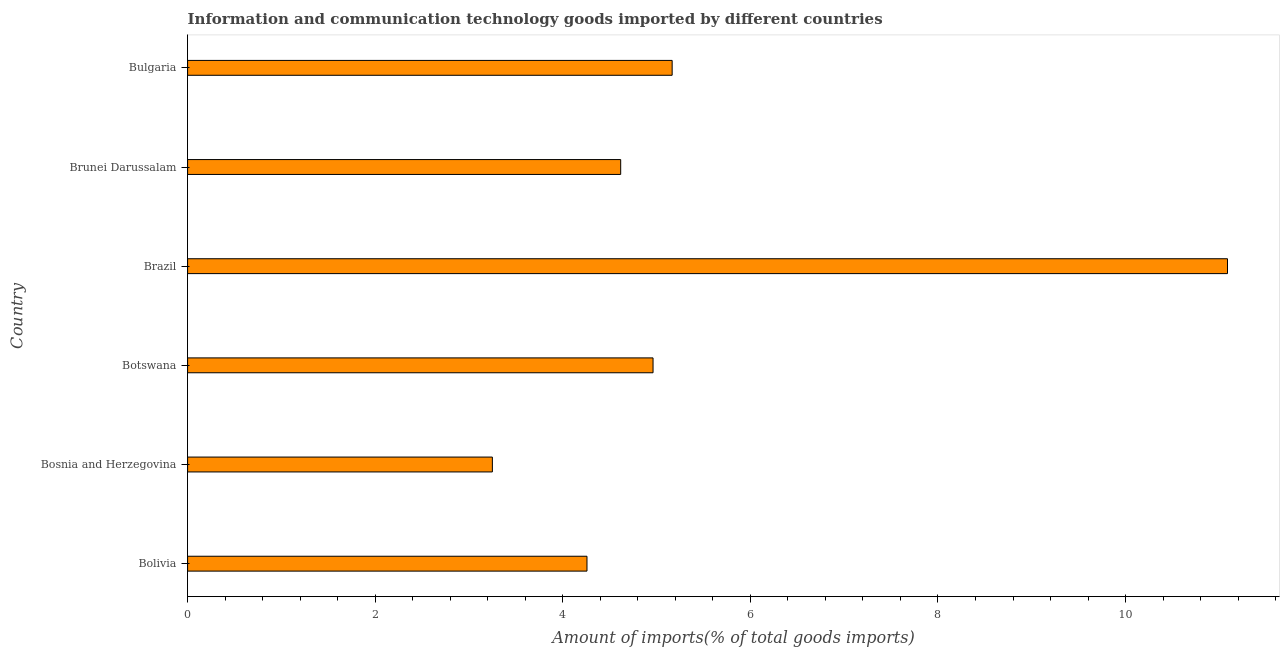Does the graph contain grids?
Your response must be concise. No. What is the title of the graph?
Your response must be concise. Information and communication technology goods imported by different countries. What is the label or title of the X-axis?
Make the answer very short. Amount of imports(% of total goods imports). What is the label or title of the Y-axis?
Offer a very short reply. Country. What is the amount of ict goods imports in Bosnia and Herzegovina?
Your answer should be compact. 3.25. Across all countries, what is the maximum amount of ict goods imports?
Provide a short and direct response. 11.09. Across all countries, what is the minimum amount of ict goods imports?
Ensure brevity in your answer.  3.25. In which country was the amount of ict goods imports minimum?
Offer a terse response. Bosnia and Herzegovina. What is the sum of the amount of ict goods imports?
Your answer should be compact. 33.34. What is the difference between the amount of ict goods imports in Botswana and Brazil?
Keep it short and to the point. -6.12. What is the average amount of ict goods imports per country?
Your answer should be compact. 5.56. What is the median amount of ict goods imports?
Your response must be concise. 4.79. In how many countries, is the amount of ict goods imports greater than 6.8 %?
Your answer should be very brief. 1. What is the ratio of the amount of ict goods imports in Bosnia and Herzegovina to that in Brazil?
Make the answer very short. 0.29. What is the difference between the highest and the second highest amount of ict goods imports?
Provide a succinct answer. 5.92. What is the difference between the highest and the lowest amount of ict goods imports?
Provide a short and direct response. 7.84. Are all the bars in the graph horizontal?
Your response must be concise. Yes. How many countries are there in the graph?
Keep it short and to the point. 6. What is the Amount of imports(% of total goods imports) of Bolivia?
Provide a short and direct response. 4.26. What is the Amount of imports(% of total goods imports) in Bosnia and Herzegovina?
Give a very brief answer. 3.25. What is the Amount of imports(% of total goods imports) of Botswana?
Your answer should be very brief. 4.96. What is the Amount of imports(% of total goods imports) in Brazil?
Provide a short and direct response. 11.09. What is the Amount of imports(% of total goods imports) in Brunei Darussalam?
Provide a short and direct response. 4.62. What is the Amount of imports(% of total goods imports) in Bulgaria?
Offer a very short reply. 5.17. What is the difference between the Amount of imports(% of total goods imports) in Bolivia and Bosnia and Herzegovina?
Ensure brevity in your answer.  1.01. What is the difference between the Amount of imports(% of total goods imports) in Bolivia and Botswana?
Your answer should be compact. -0.7. What is the difference between the Amount of imports(% of total goods imports) in Bolivia and Brazil?
Offer a terse response. -6.83. What is the difference between the Amount of imports(% of total goods imports) in Bolivia and Brunei Darussalam?
Provide a succinct answer. -0.36. What is the difference between the Amount of imports(% of total goods imports) in Bolivia and Bulgaria?
Give a very brief answer. -0.91. What is the difference between the Amount of imports(% of total goods imports) in Bosnia and Herzegovina and Botswana?
Ensure brevity in your answer.  -1.71. What is the difference between the Amount of imports(% of total goods imports) in Bosnia and Herzegovina and Brazil?
Make the answer very short. -7.84. What is the difference between the Amount of imports(% of total goods imports) in Bosnia and Herzegovina and Brunei Darussalam?
Ensure brevity in your answer.  -1.37. What is the difference between the Amount of imports(% of total goods imports) in Bosnia and Herzegovina and Bulgaria?
Offer a very short reply. -1.92. What is the difference between the Amount of imports(% of total goods imports) in Botswana and Brazil?
Ensure brevity in your answer.  -6.12. What is the difference between the Amount of imports(% of total goods imports) in Botswana and Brunei Darussalam?
Offer a very short reply. 0.34. What is the difference between the Amount of imports(% of total goods imports) in Botswana and Bulgaria?
Provide a succinct answer. -0.2. What is the difference between the Amount of imports(% of total goods imports) in Brazil and Brunei Darussalam?
Your answer should be very brief. 6.47. What is the difference between the Amount of imports(% of total goods imports) in Brazil and Bulgaria?
Offer a terse response. 5.92. What is the difference between the Amount of imports(% of total goods imports) in Brunei Darussalam and Bulgaria?
Ensure brevity in your answer.  -0.55. What is the ratio of the Amount of imports(% of total goods imports) in Bolivia to that in Bosnia and Herzegovina?
Your answer should be compact. 1.31. What is the ratio of the Amount of imports(% of total goods imports) in Bolivia to that in Botswana?
Your answer should be very brief. 0.86. What is the ratio of the Amount of imports(% of total goods imports) in Bolivia to that in Brazil?
Provide a short and direct response. 0.38. What is the ratio of the Amount of imports(% of total goods imports) in Bolivia to that in Brunei Darussalam?
Provide a short and direct response. 0.92. What is the ratio of the Amount of imports(% of total goods imports) in Bolivia to that in Bulgaria?
Your answer should be compact. 0.82. What is the ratio of the Amount of imports(% of total goods imports) in Bosnia and Herzegovina to that in Botswana?
Keep it short and to the point. 0.66. What is the ratio of the Amount of imports(% of total goods imports) in Bosnia and Herzegovina to that in Brazil?
Make the answer very short. 0.29. What is the ratio of the Amount of imports(% of total goods imports) in Bosnia and Herzegovina to that in Brunei Darussalam?
Give a very brief answer. 0.7. What is the ratio of the Amount of imports(% of total goods imports) in Bosnia and Herzegovina to that in Bulgaria?
Make the answer very short. 0.63. What is the ratio of the Amount of imports(% of total goods imports) in Botswana to that in Brazil?
Provide a short and direct response. 0.45. What is the ratio of the Amount of imports(% of total goods imports) in Botswana to that in Brunei Darussalam?
Make the answer very short. 1.07. What is the ratio of the Amount of imports(% of total goods imports) in Botswana to that in Bulgaria?
Keep it short and to the point. 0.96. What is the ratio of the Amount of imports(% of total goods imports) in Brazil to that in Brunei Darussalam?
Give a very brief answer. 2.4. What is the ratio of the Amount of imports(% of total goods imports) in Brazil to that in Bulgaria?
Provide a succinct answer. 2.15. What is the ratio of the Amount of imports(% of total goods imports) in Brunei Darussalam to that in Bulgaria?
Give a very brief answer. 0.89. 